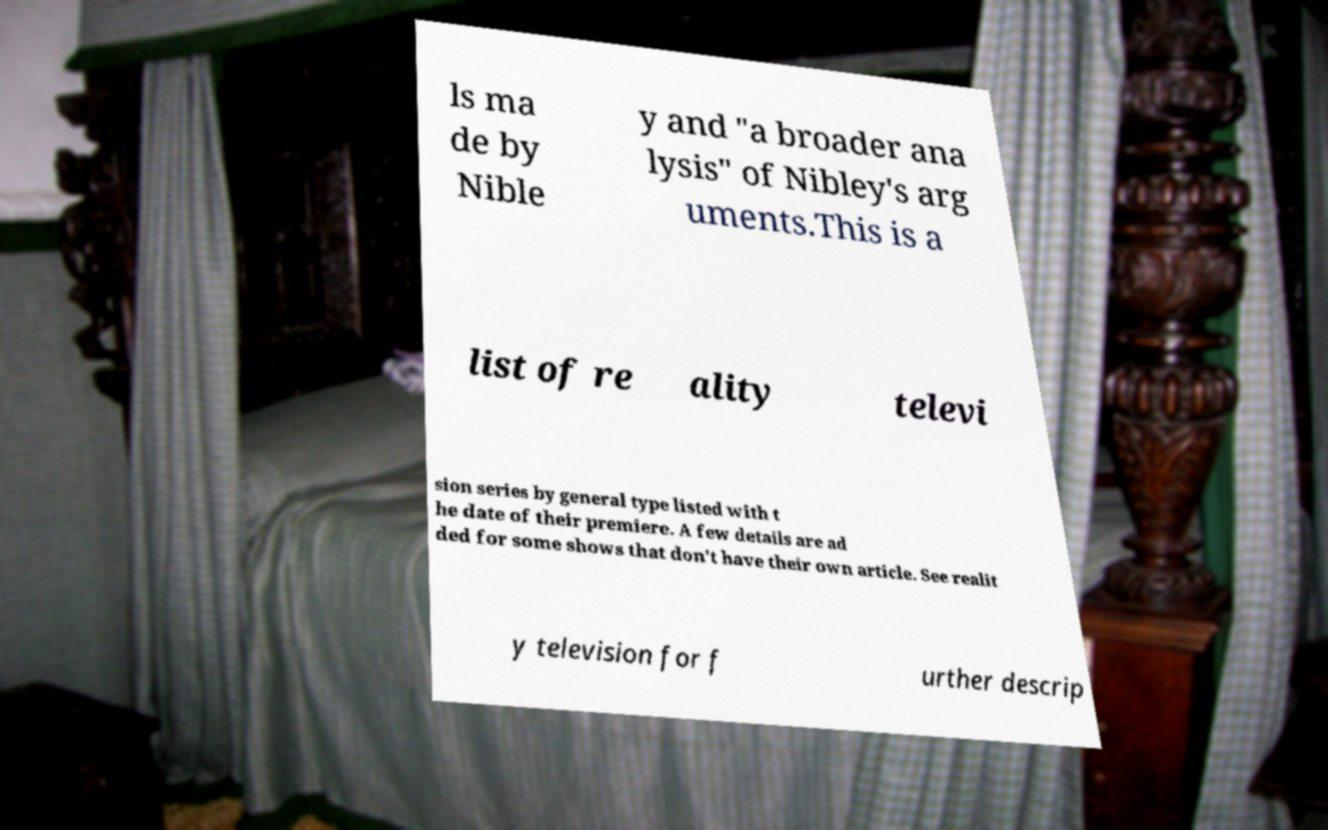What messages or text are displayed in this image? I need them in a readable, typed format. ls ma de by Nible y and "a broader ana lysis" of Nibley's arg uments.This is a list of re ality televi sion series by general type listed with t he date of their premiere. A few details are ad ded for some shows that don't have their own article. See realit y television for f urther descrip 